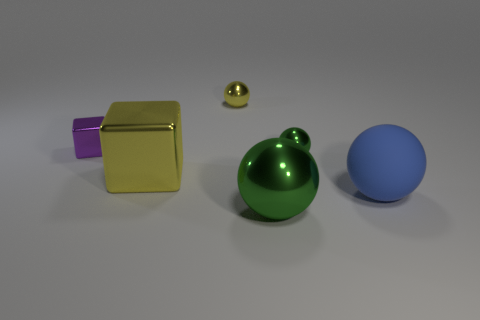Subtract all blocks. How many objects are left? 4 Subtract 1 blocks. How many blocks are left? 1 Subtract all brown spheres. Subtract all brown cylinders. How many spheres are left? 4 Subtract all red blocks. How many green spheres are left? 2 Subtract all green metal spheres. Subtract all tiny cubes. How many objects are left? 3 Add 5 big shiny things. How many big shiny things are left? 7 Add 5 small brown metallic cylinders. How many small brown metallic cylinders exist? 5 Add 1 small shiny things. How many objects exist? 7 Subtract all yellow blocks. How many blocks are left? 1 Subtract all yellow shiny spheres. How many spheres are left? 3 